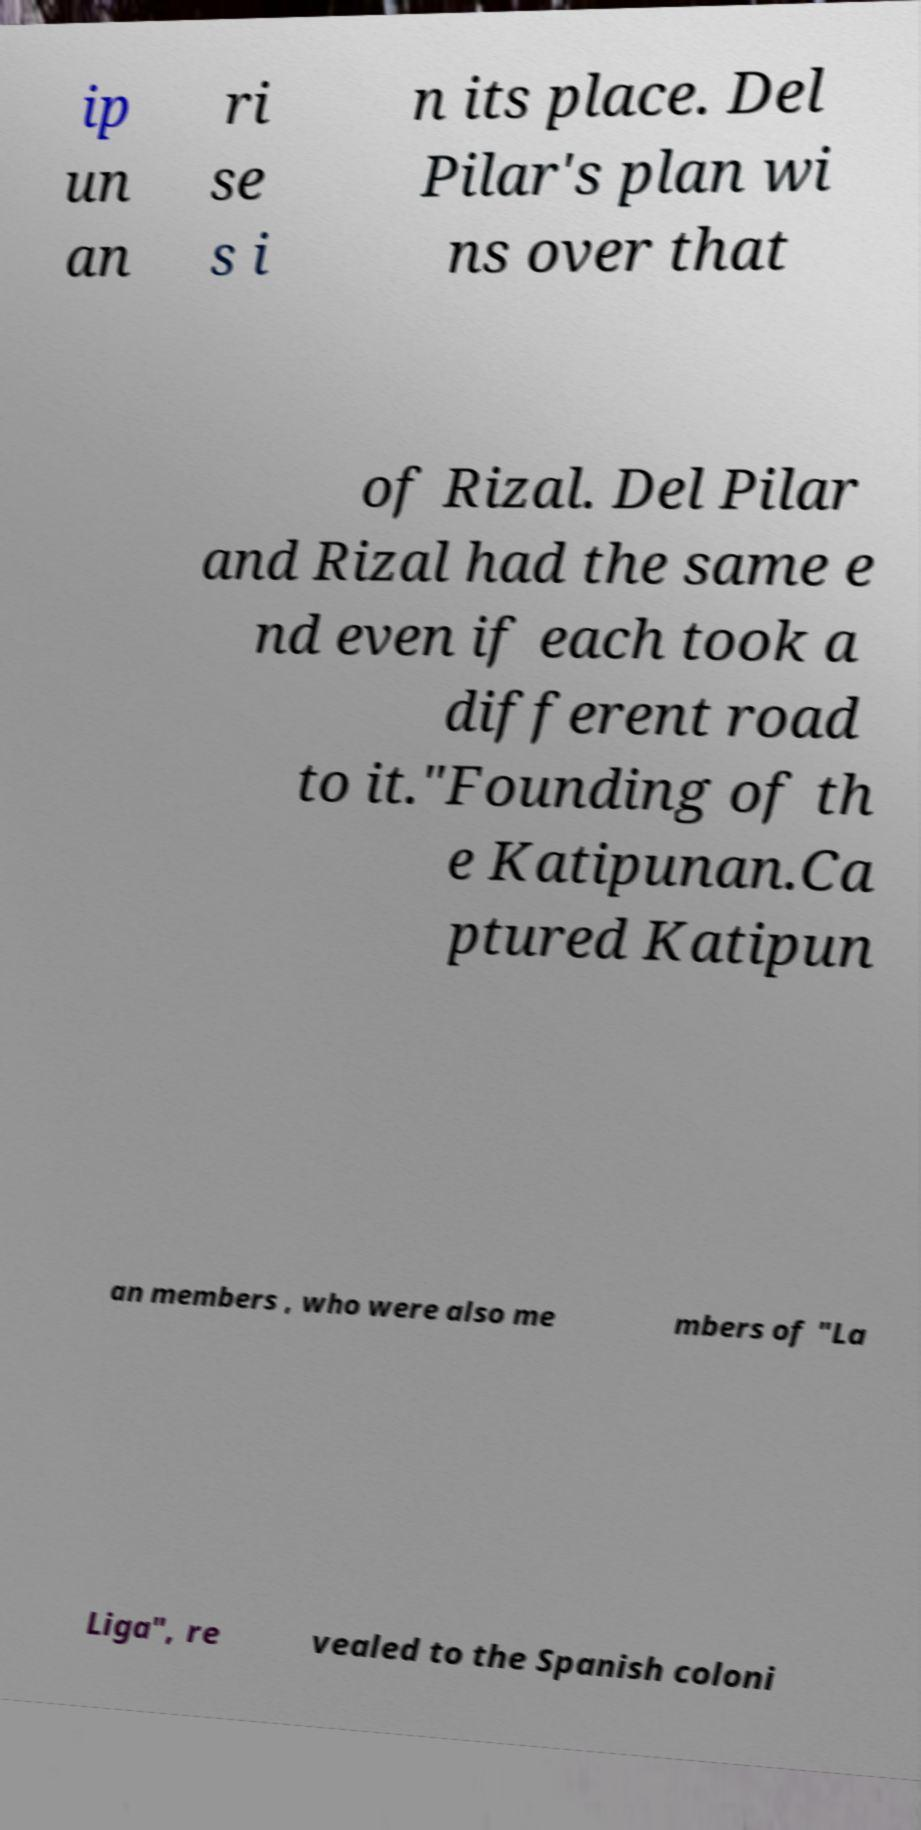What messages or text are displayed in this image? I need them in a readable, typed format. ip un an ri se s i n its place. Del Pilar's plan wi ns over that of Rizal. Del Pilar and Rizal had the same e nd even if each took a different road to it."Founding of th e Katipunan.Ca ptured Katipun an members , who were also me mbers of "La Liga", re vealed to the Spanish coloni 